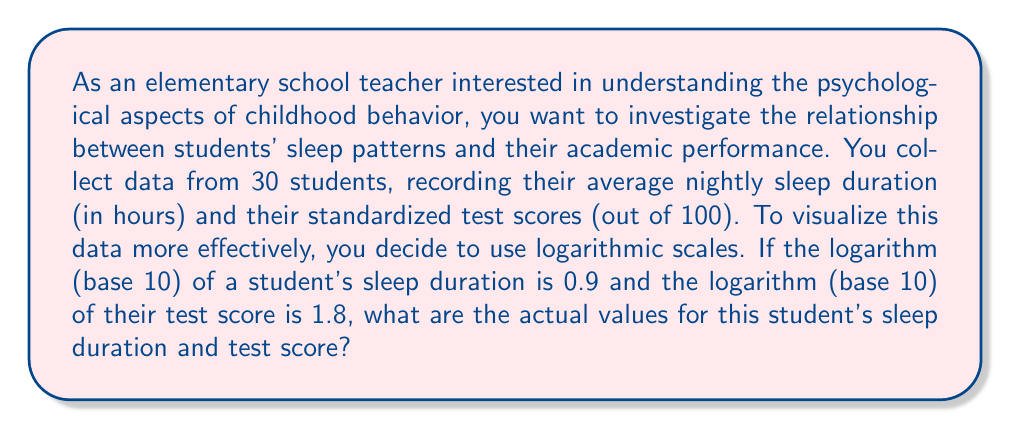Show me your answer to this math problem. To solve this problem, we need to understand the concept of logarithms and how to convert logarithmic values back to their original form. Let's break it down step by step:

1. For sleep duration:
   The given information is $\log_{10}(x) = 0.9$, where $x$ is the sleep duration in hours.
   To find $x$, we need to use the inverse operation, which is raising 10 to the power of 0.9:
   
   $x = 10^{0.9}$

   Using a calculator or computer, we can calculate this value:
   $x \approx 7.94$ hours

2. For test score:
   The given information is $\log_{10}(y) = 1.8$, where $y$ is the test score.
   Again, we use the inverse operation:
   
   $y = 10^{1.8}$

   Calculating this value:
   $y \approx 63.10$

3. Since test scores are typically whole numbers, we round 63.10 to 63.

This approach demonstrates how logarithmic scales can compress wide ranges of values, making it easier to visualize and analyze relationships between variables with different magnitudes. In this case, it allows for a more balanced comparison between sleep duration (typically ranging from 5 to 10 hours) and test scores (ranging from 0 to 100).
Answer: The student's actual sleep duration is approximately 7.94 hours, and their test score is 63. 